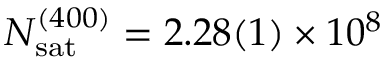Convert formula to latex. <formula><loc_0><loc_0><loc_500><loc_500>{ N _ { s a t } } ^ { ( 4 0 0 ) } = 2 . 2 8 ( 1 ) \times 1 0 ^ { 8 }</formula> 